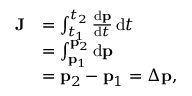<formula> <loc_0><loc_0><loc_500><loc_500>{ \begin{array} { r l } { J } & { = \int _ { t _ { 1 } } ^ { t _ { 2 } } { \frac { d p } { d t } } \, d t } \\ & { = \int _ { p _ { 1 } } ^ { p _ { 2 } } d p } \\ & { = p _ { 2 } - p _ { 1 } = \Delta p , } \end{array} }</formula> 